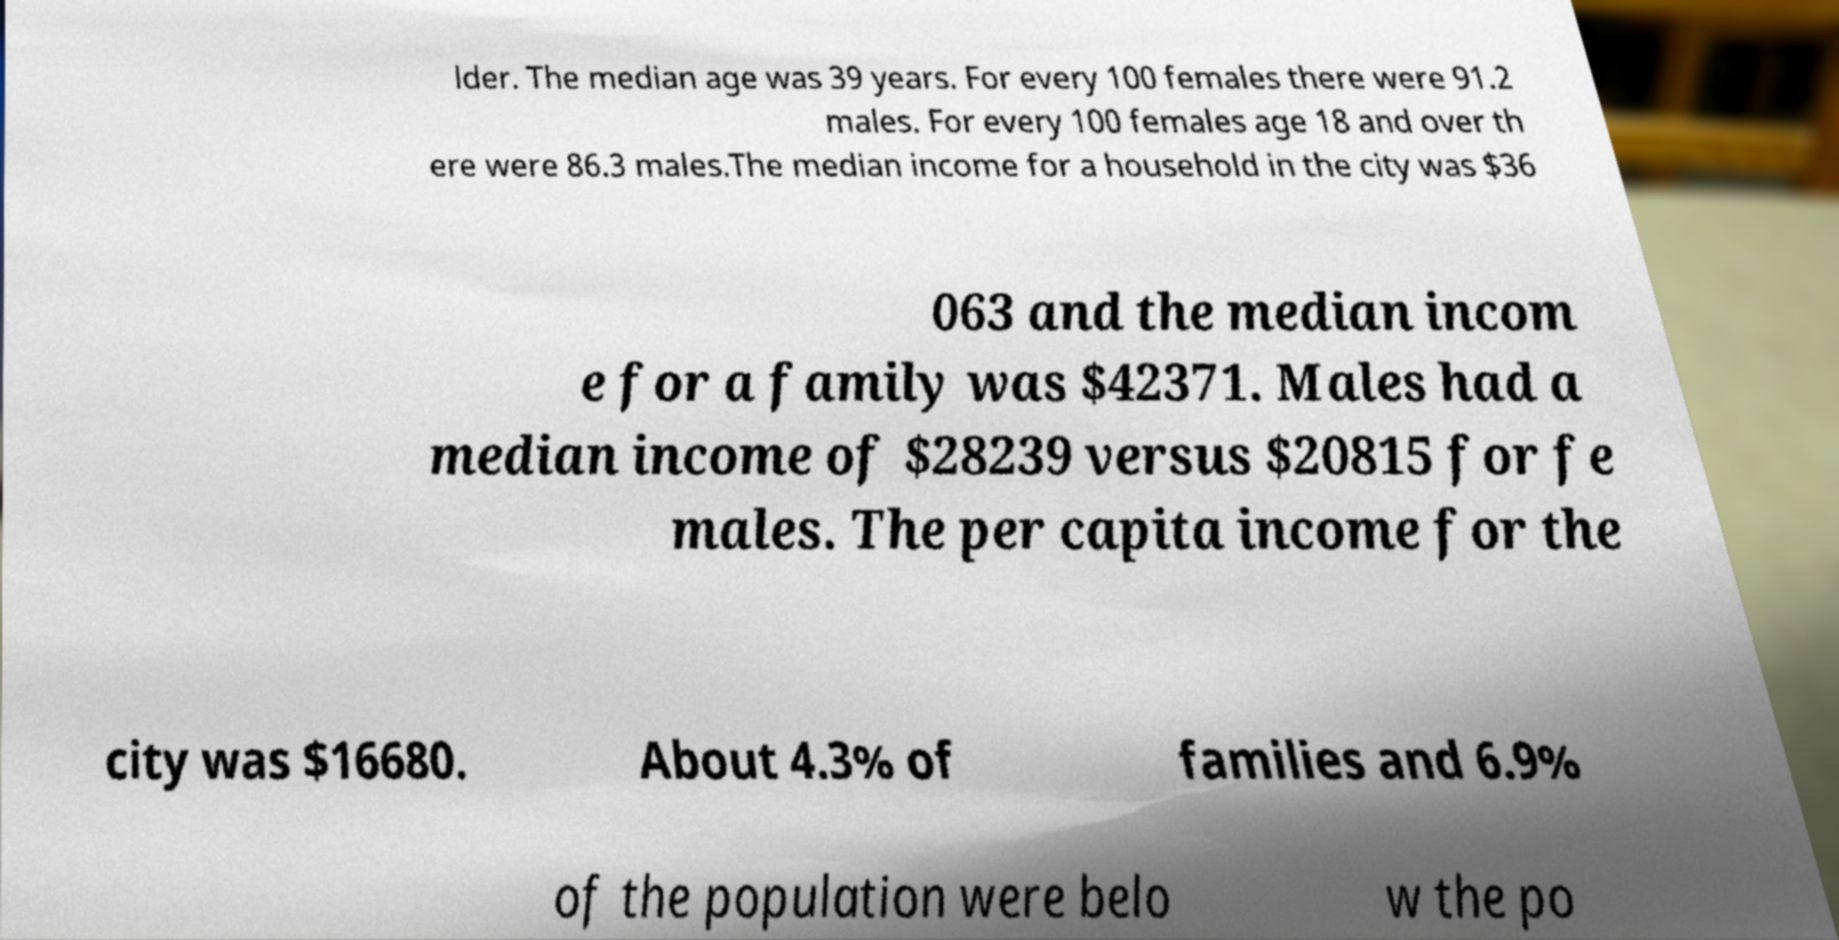Could you assist in decoding the text presented in this image and type it out clearly? lder. The median age was 39 years. For every 100 females there were 91.2 males. For every 100 females age 18 and over th ere were 86.3 males.The median income for a household in the city was $36 063 and the median incom e for a family was $42371. Males had a median income of $28239 versus $20815 for fe males. The per capita income for the city was $16680. About 4.3% of families and 6.9% of the population were belo w the po 